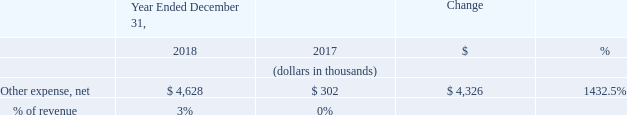Other Expense, Net
Other expense, net decreased by $4.3 million in 2018 compared to 2017 as a result of an increase in interest expense of $5.7 million related to interest expense due under our convertible senior notes. This increase was offset by an increase of $1.4 million of interest income earned on our short-term investments.
What was the decrease in the Other expense, net in 2018? $4.3 million. What was the Other expense, net in 2018 and 2017 respectively?
Answer scale should be: thousand. 4,628, 302. What is the % change for other expense, net between 2017 and 2018?
Answer scale should be: percent. 1432.5. What is the average Other expense, net for 2017 and 2018?
Answer scale should be: thousand. (4,628 + 302) / 2
Answer: 2465. In which year was Other expense, net less than 1,000 thousands? Locate and analyze other expense in row 4
answer: 2017. What is the change in the % of revenue between 2017 and 2018?
Answer scale should be: percent. 3 - 0
Answer: 3. 